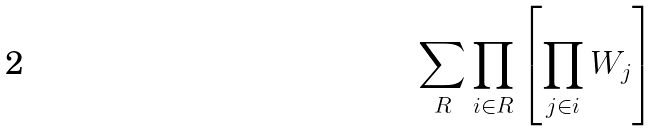<formula> <loc_0><loc_0><loc_500><loc_500>\sum _ { R } \prod _ { i \in R } \left [ \prod _ { j \in i } W _ { j } \right ]</formula> 